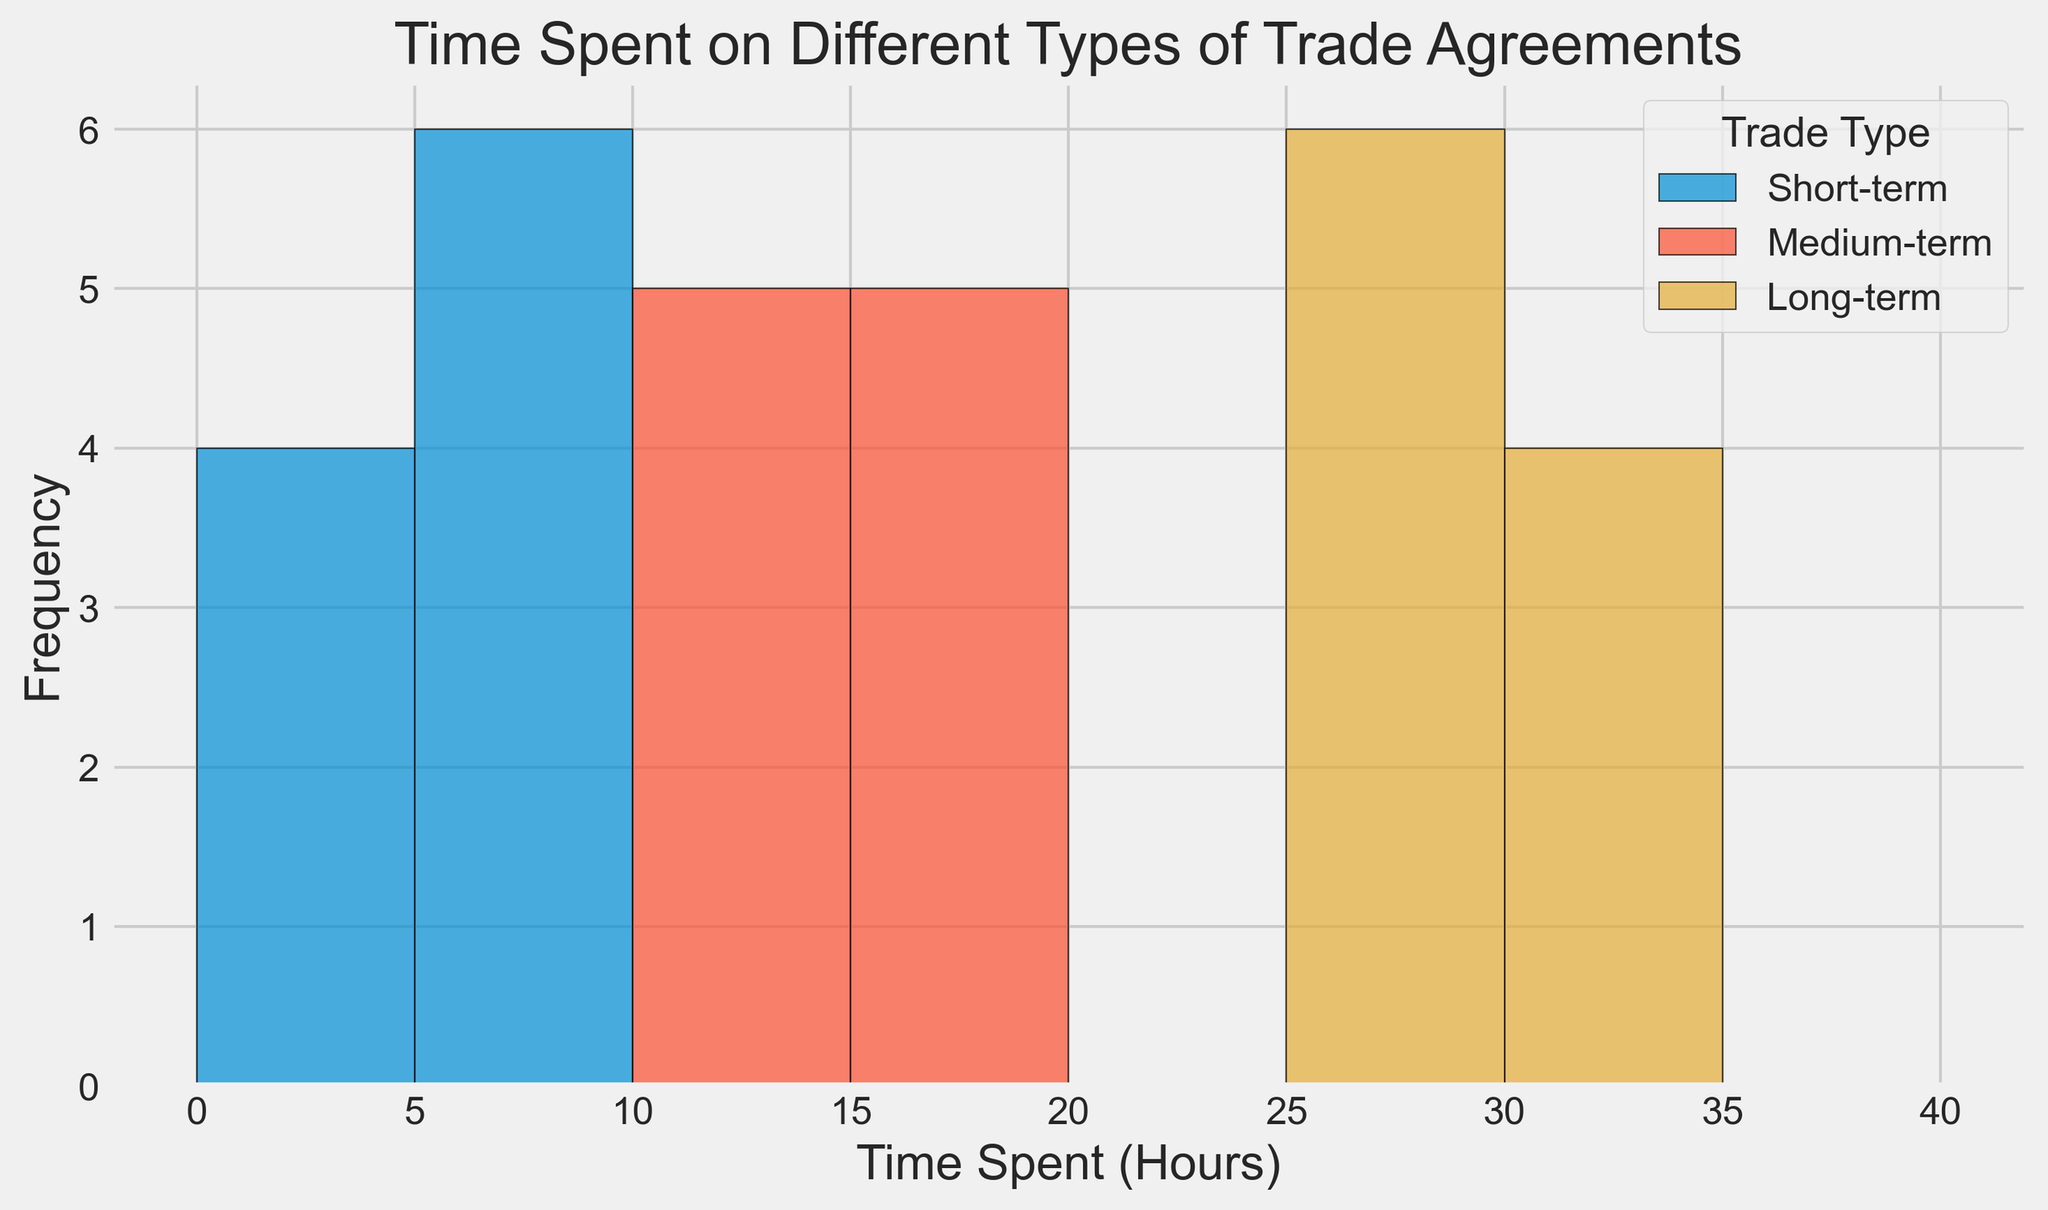What's the most common time spent on short-term agreements? To determine this, look at the histogram for the Short-term trade type and identify the bar with the greatest height. This represents the time spent that occurs most frequently.
Answer: 5 hours Which trade type has the widest range of time spent? Evaluate the range of time spent for each trade type. Short-term ranges from 3 to 7, Medium-term from 12 to 17, and Long-term from 25 to 32. Compare these ranges.
Answer: Long-term Do more people spend between 15 and 20 hours on Medium-term agreements or between 20 and 25 hours on Long-term agreements? Find the bars representing 15-20 hours for Medium-term and 20-25 hours for Long-term. Compare the heights of these bars.
Answer: Medium-term What's the average time spent on Long-term agreements? Calculate the average by summing the time values for Long-term and dividing by the number of occurrences. (30+25+32+28+31+26+29+27+30+28)/10 = 28.6
Answer: 28.6 hours Which trade type shows the highest single frequency? Identify the highest bar in the histogram and note its associated trade type and time spent.
Answer: Medium-term at 15 hours Is the median time spent on Short-term agreements greater or less than 5 hours? List and sort the Short-term values: [3, 3, 4, 4, 5, 5, 5, 6, 6, 7]. The median value is the middle point: 5.
Answer: Equal to 5 hours For which trade type does the time spread look more evenly distributed? Compare the shape and spread of the bars for each trade type. The more even the bars, the more evenly distributed the time spent.
Answer: Long-term How many time spent categories (bins) are defined in the histogram? Count the number of distinct bins or categories along the x-axis within the data range.
Answer: 8 bins Which trade agreement type has the lowest maximum time spent and what is it? Identify the highest value for each trade type. Compare these values to determine the lowest maximum.
Answer: Short-term, 7 hours 